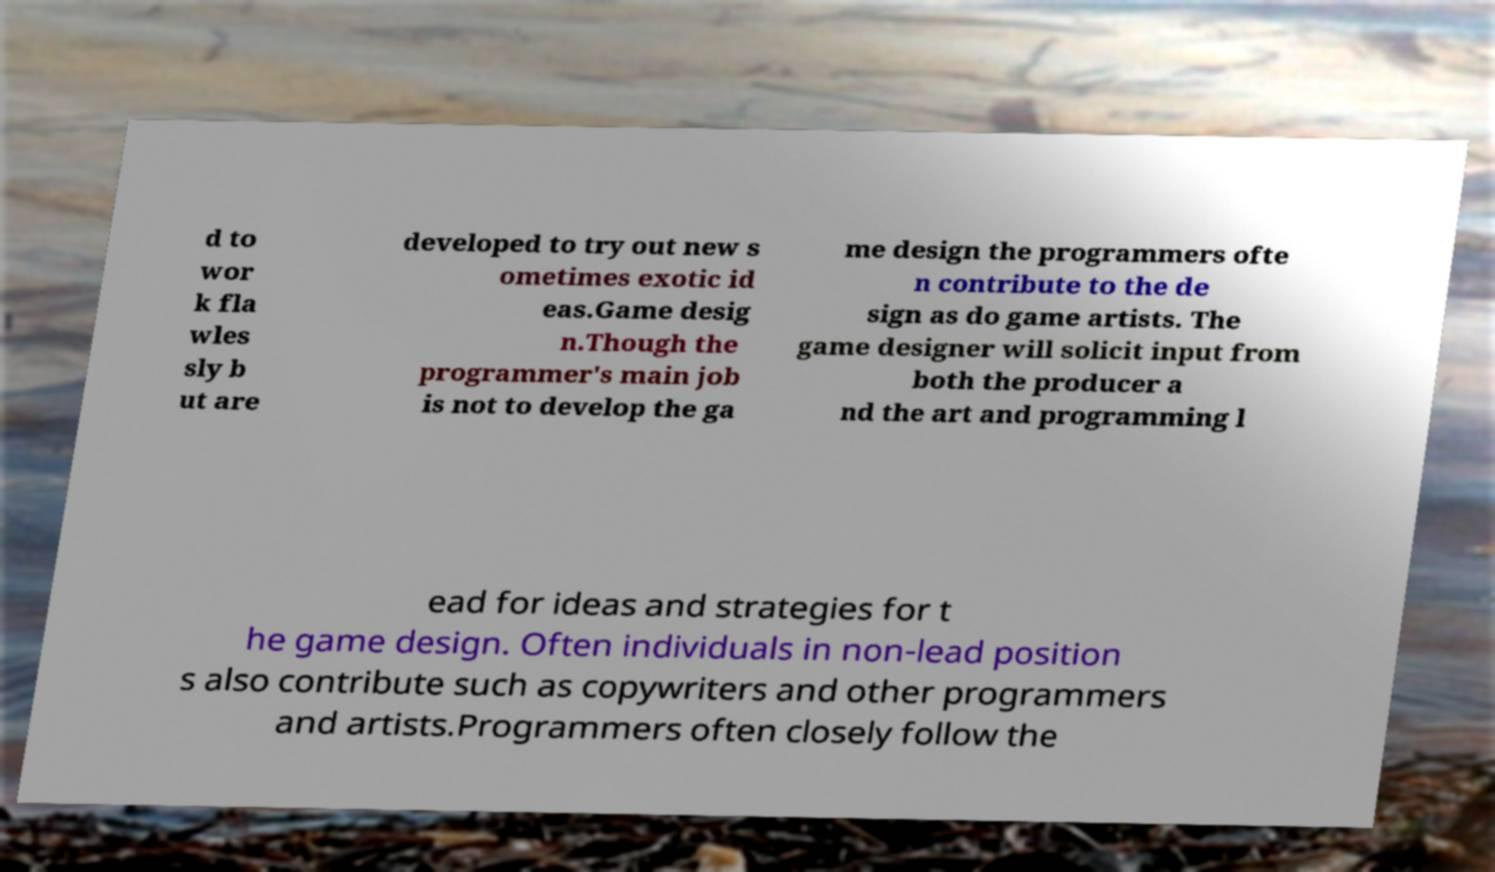What messages or text are displayed in this image? I need them in a readable, typed format. d to wor k fla wles sly b ut are developed to try out new s ometimes exotic id eas.Game desig n.Though the programmer's main job is not to develop the ga me design the programmers ofte n contribute to the de sign as do game artists. The game designer will solicit input from both the producer a nd the art and programming l ead for ideas and strategies for t he game design. Often individuals in non-lead position s also contribute such as copywriters and other programmers and artists.Programmers often closely follow the 